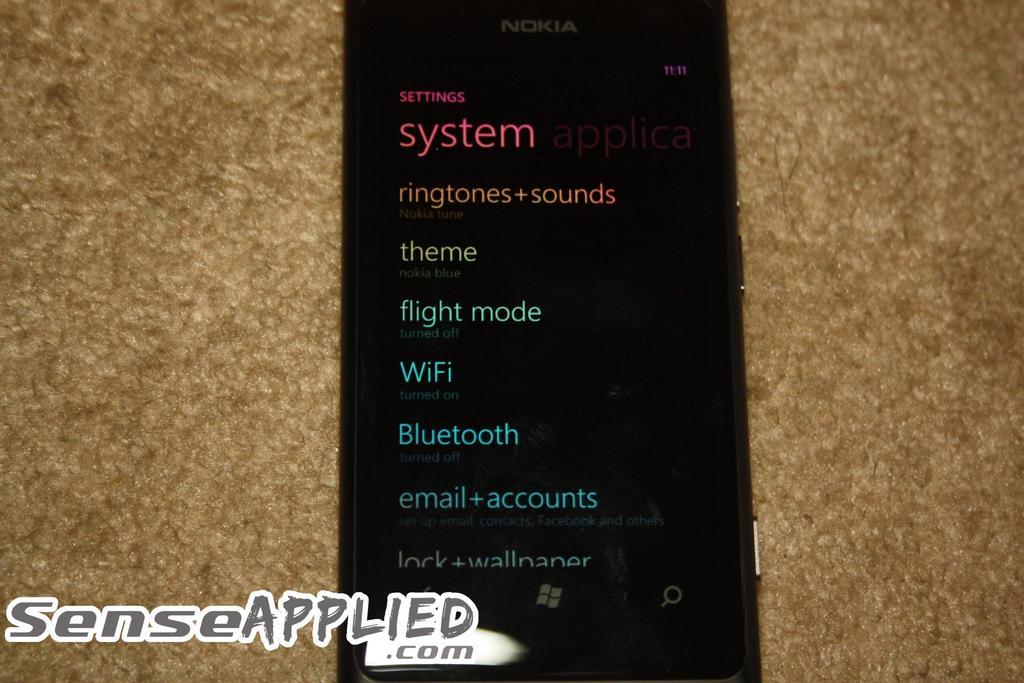What is the url listed at the bottom?
Give a very brief answer. Senseapplied.com. What is this screen called?
Your answer should be compact. Settings. 